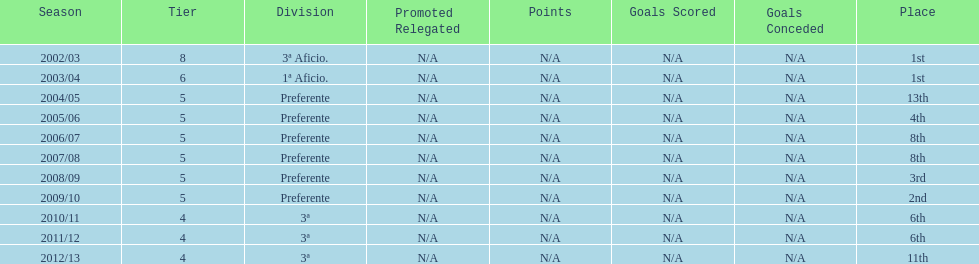Which division has the largest number of ranks? Preferente. 